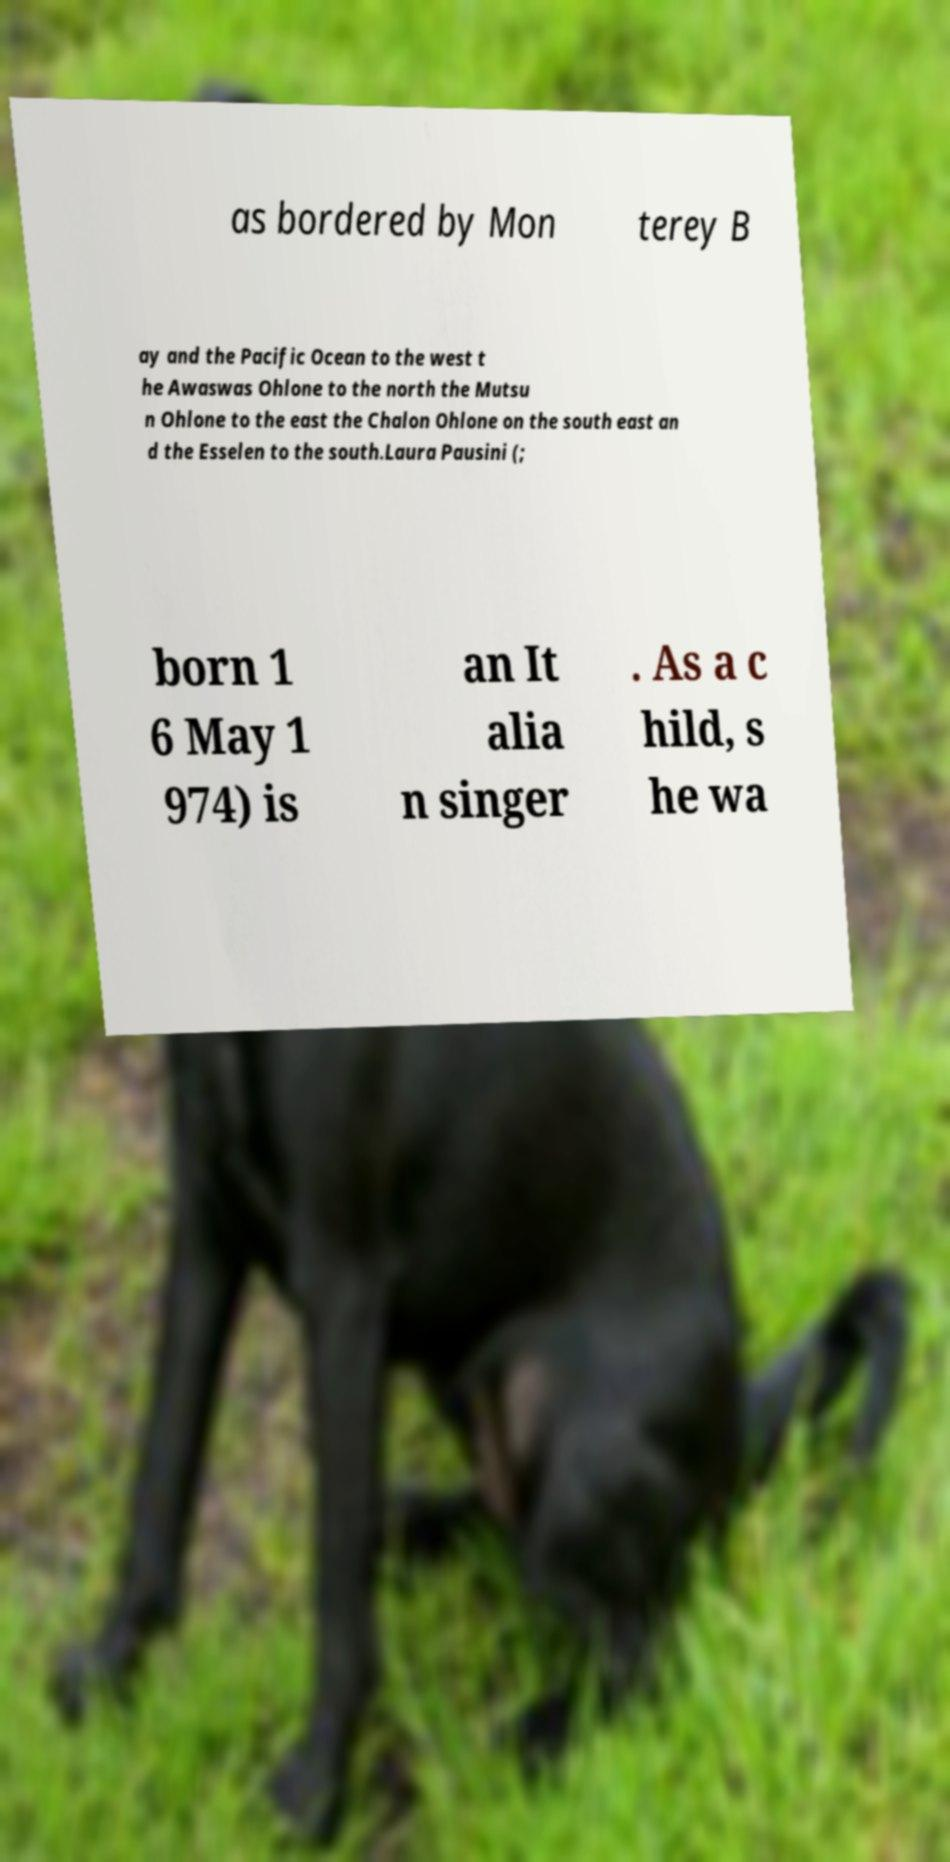Could you extract and type out the text from this image? as bordered by Mon terey B ay and the Pacific Ocean to the west t he Awaswas Ohlone to the north the Mutsu n Ohlone to the east the Chalon Ohlone on the south east an d the Esselen to the south.Laura Pausini (; born 1 6 May 1 974) is an It alia n singer . As a c hild, s he wa 